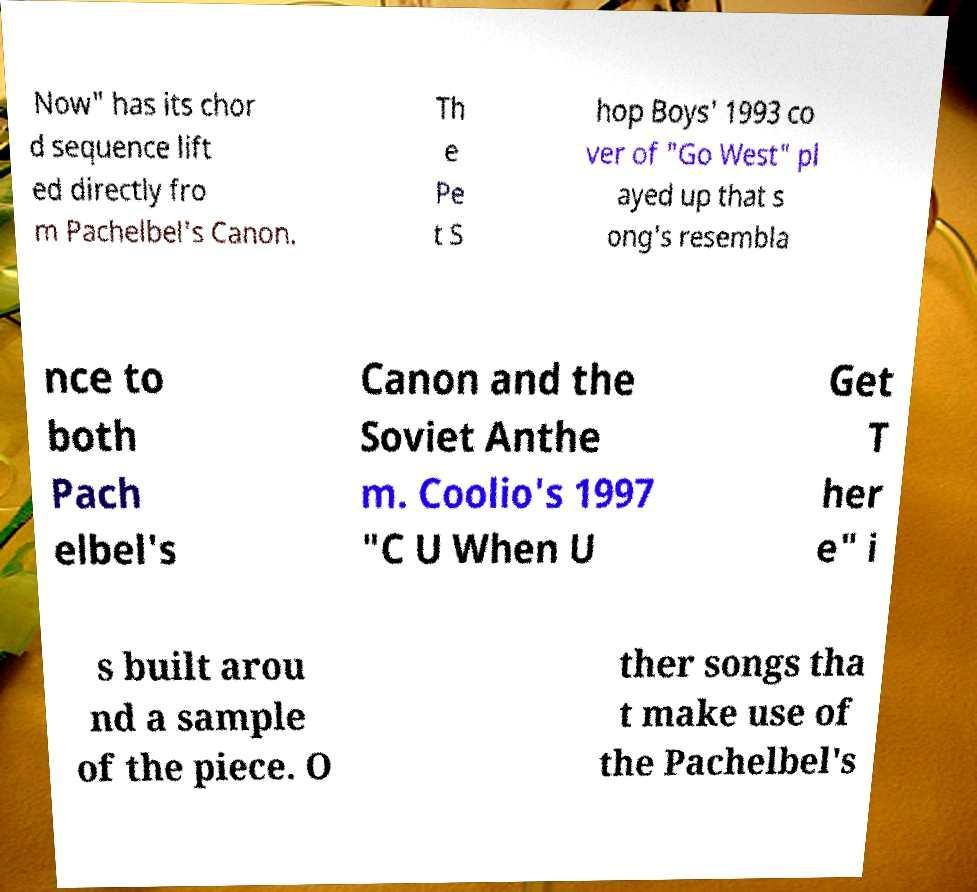Please read and relay the text visible in this image. What does it say? Now" has its chor d sequence lift ed directly fro m Pachelbel's Canon. Th e Pe t S hop Boys' 1993 co ver of "Go West" pl ayed up that s ong's resembla nce to both Pach elbel's Canon and the Soviet Anthe m. Coolio's 1997 "C U When U Get T her e" i s built arou nd a sample of the piece. O ther songs tha t make use of the Pachelbel's 